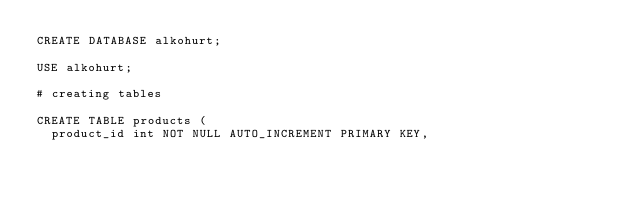Convert code to text. <code><loc_0><loc_0><loc_500><loc_500><_SQL_>CREATE DATABASE alkohurt;

USE alkohurt;

# creating tables

CREATE TABLE products (
  product_id int NOT NULL AUTO_INCREMENT PRIMARY KEY,</code> 